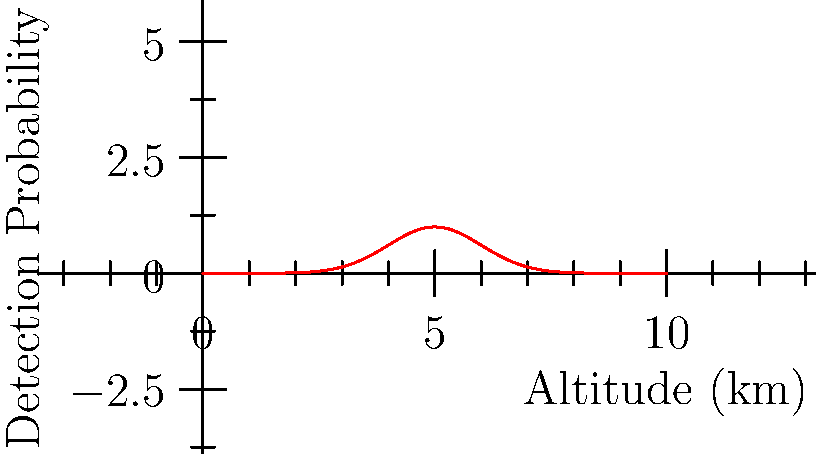The graph represents the probability of drone detection based on altitude, following a normal distribution. If the optimal flight altitude for minimal detection is 5 km and the standard deviation is 1 km, what is the probability of detection when flying at 7 km altitude relative to the peak detection probability? To solve this problem, we need to use the properties of the normal distribution:

1) The peak of the bell curve represents the mean (μ), which is 5 km in this case.
2) We're given that the standard deviation (σ) is 1 km.
3) We want to find the relative probability at 7 km compared to the peak.

Let's use the formula for the normal distribution probability density function:

$$ f(x) = \frac{1}{\sigma\sqrt{2\pi}} e^{-\frac{1}{2}(\frac{x-\mu}{\sigma})^2} $$

For the relative probability, we don't need the normalization factor. We can simplify to:

$$ f(x) \propto e^{-\frac{1}{2}(\frac{x-\mu}{\sigma})^2} $$

At the peak (x = μ), the exponent is zero, so the relative probability is 1.

At 7 km:
$$ f(7) \propto e^{-\frac{1}{2}(\frac{7-5}{1})^2} = e^{-\frac{1}{2}(2)^2} = e^{-2} $$

The value of $e^{-2}$ is approximately 0.1353.

Therefore, the probability of detection at 7 km is about 13.53% of the peak detection probability.
Answer: 13.53% 